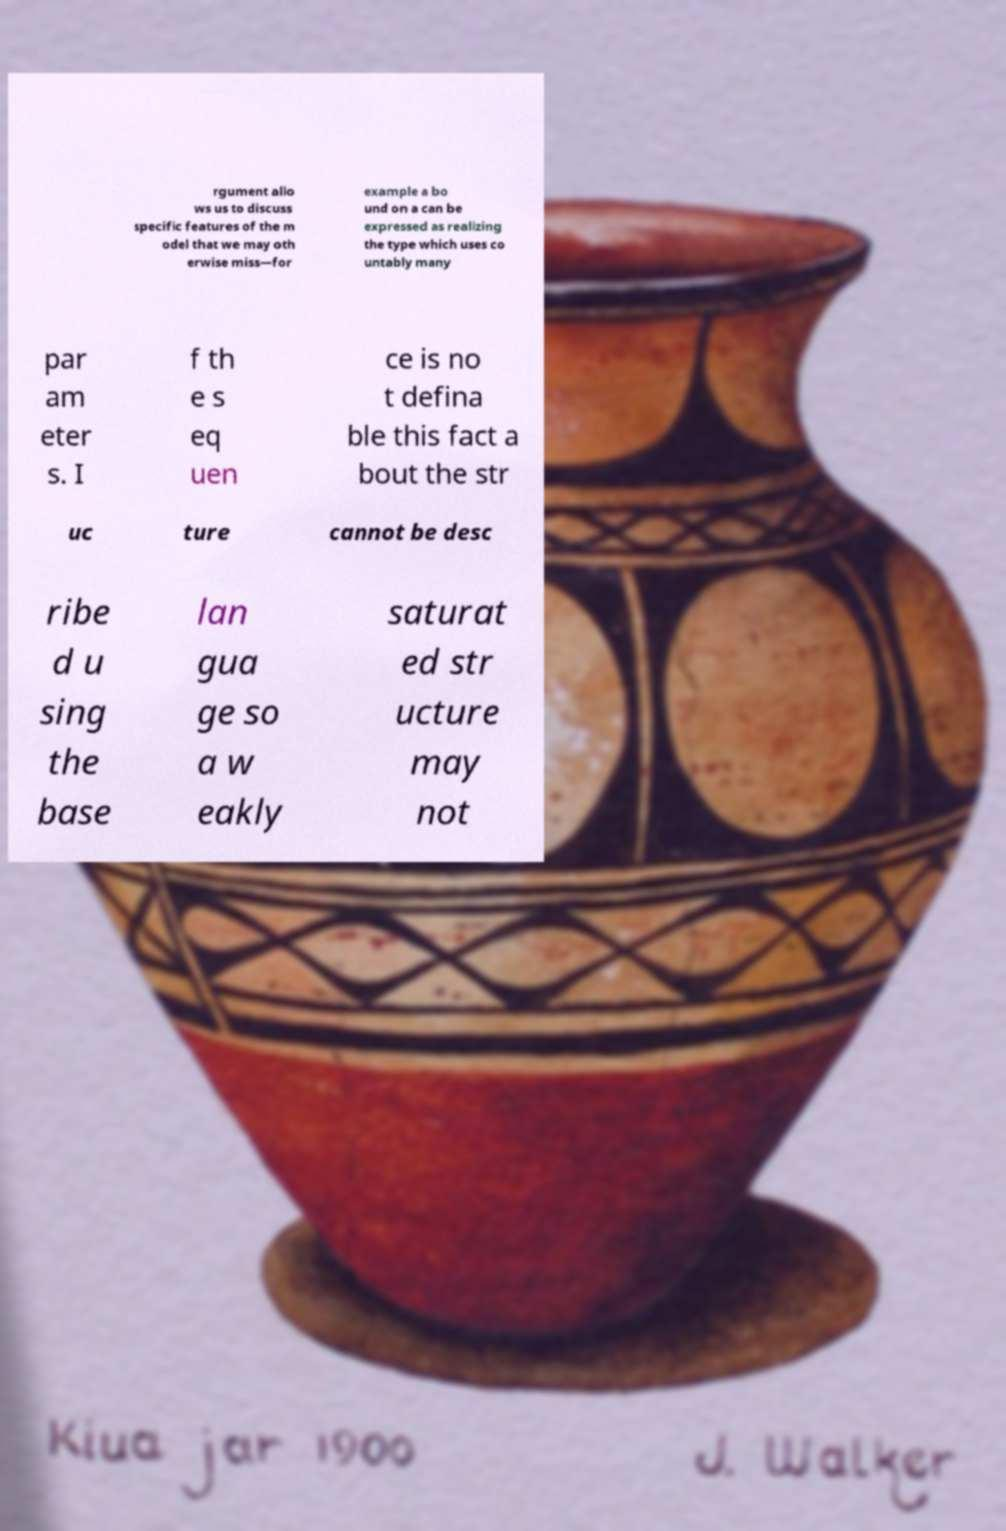Can you read and provide the text displayed in the image?This photo seems to have some interesting text. Can you extract and type it out for me? rgument allo ws us to discuss specific features of the m odel that we may oth erwise miss—for example a bo und on a can be expressed as realizing the type which uses co untably many par am eter s. I f th e s eq uen ce is no t defina ble this fact a bout the str uc ture cannot be desc ribe d u sing the base lan gua ge so a w eakly saturat ed str ucture may not 